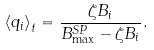Convert formula to latex. <formula><loc_0><loc_0><loc_500><loc_500>\left < q _ { i } \right > _ { t } = \frac { \zeta B _ { i } } { B _ { \max } ^ { S P } - \zeta B _ { i } } .</formula> 